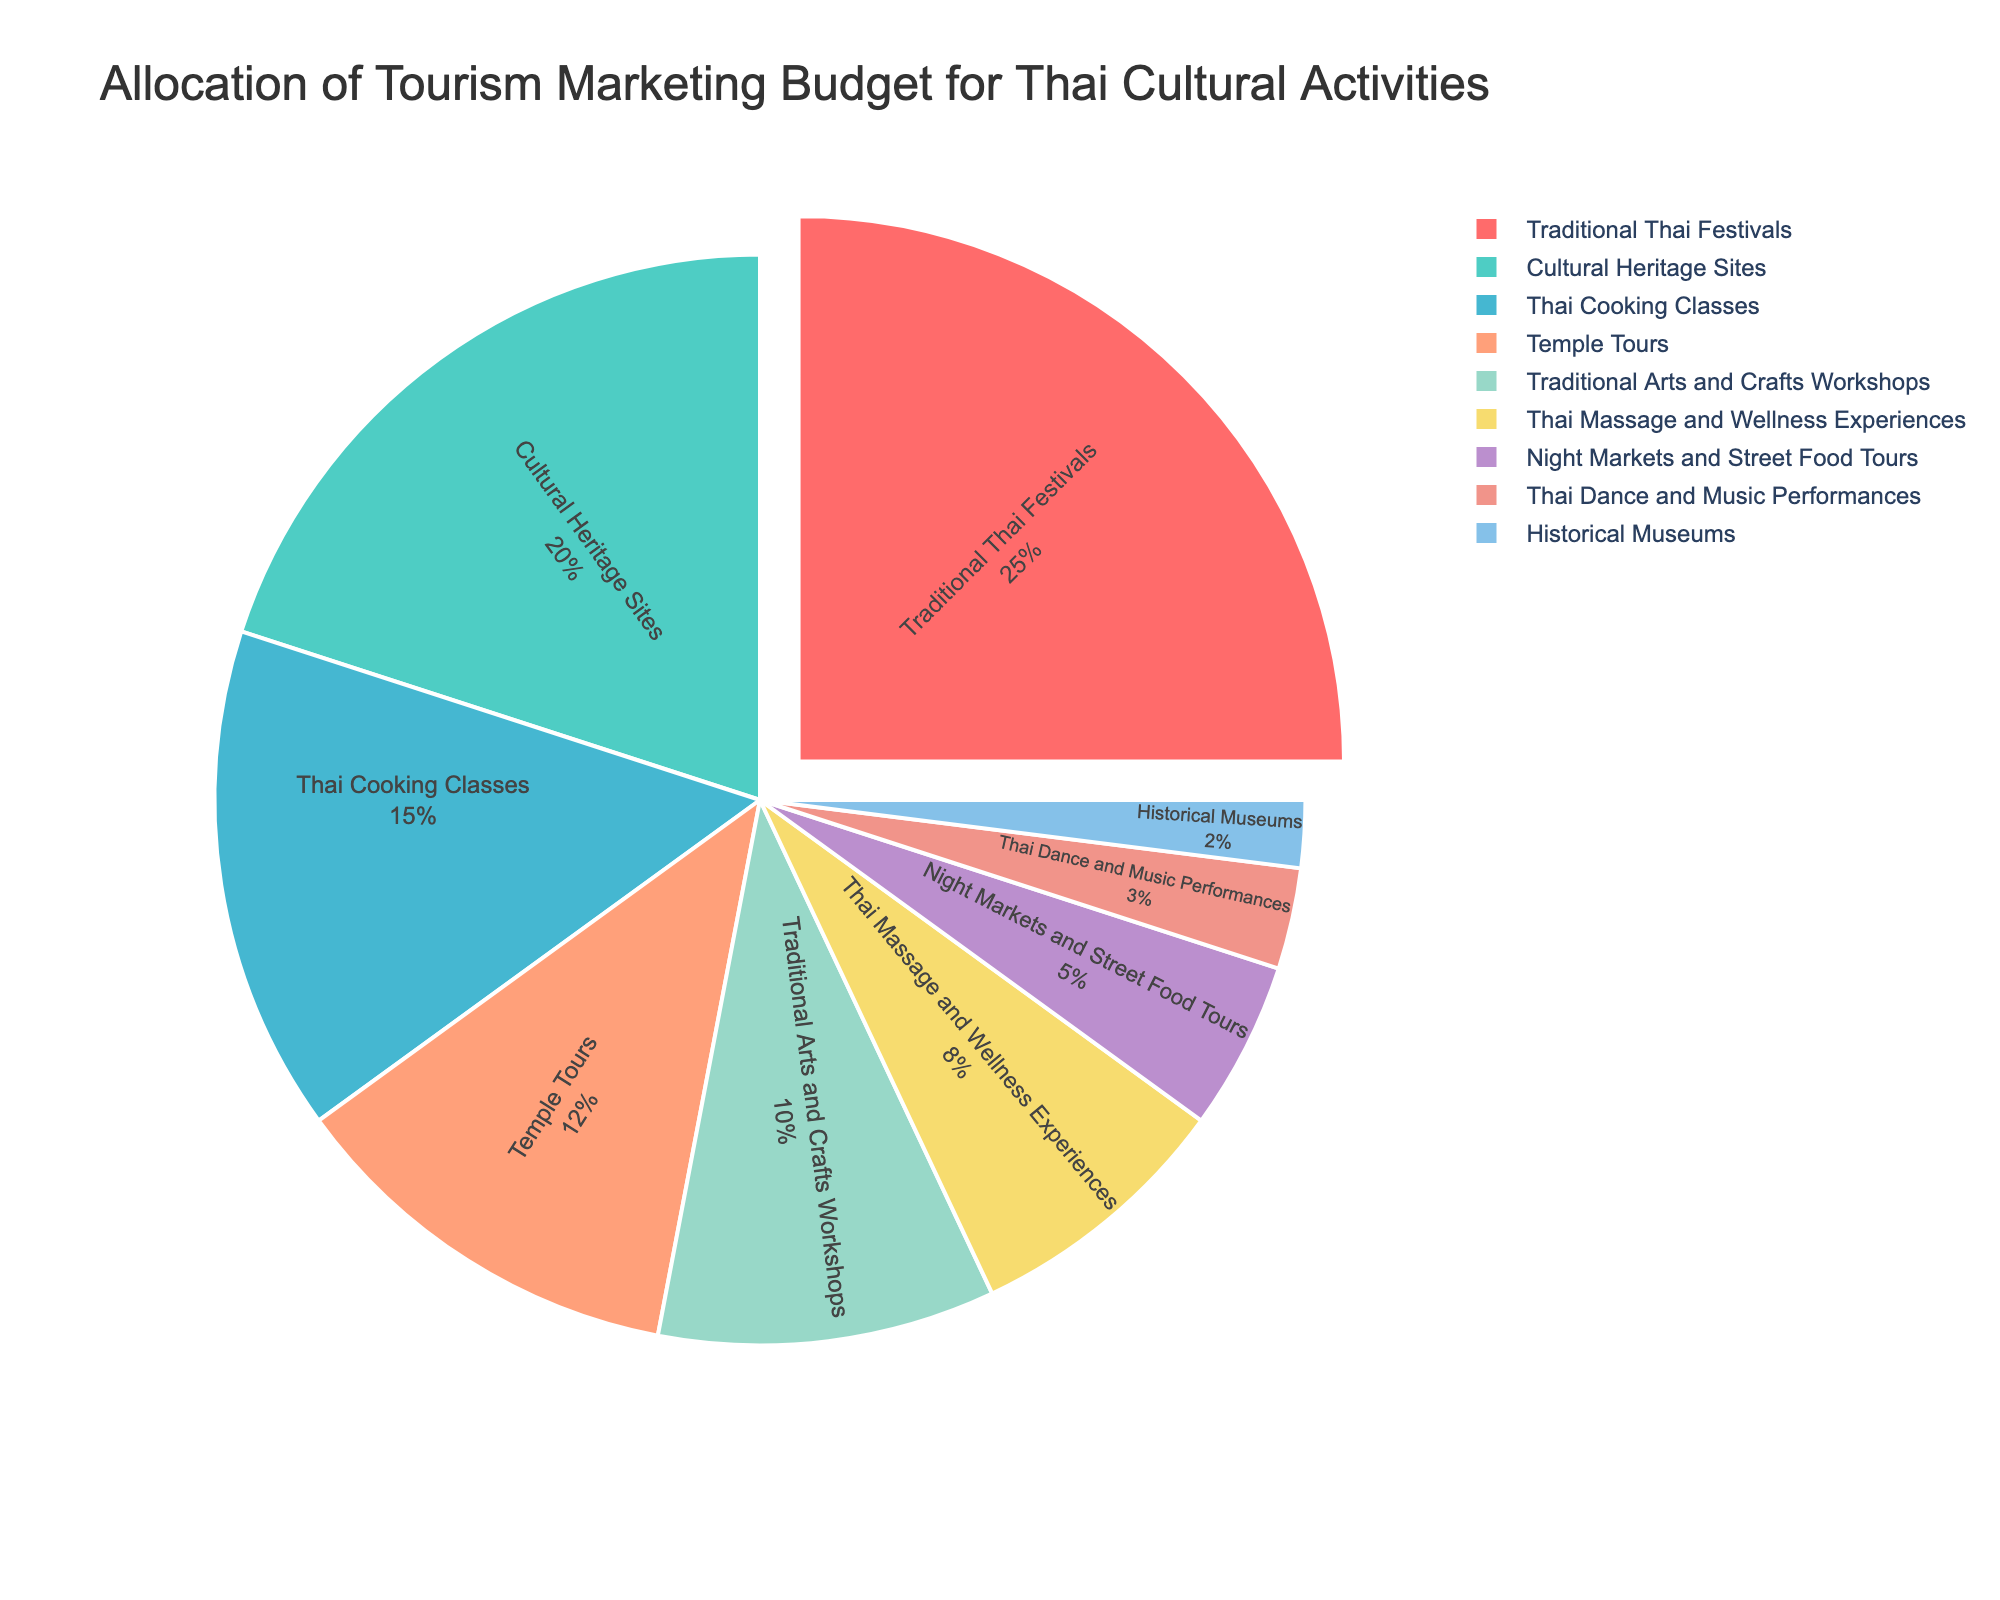What's the largest budget allocation? The pie chart shows that the largest portion of the budget is assigned to Traditional Thai Festivals. This can be seen as it occupies the largest segment of the pie chart.
Answer: 25% Which activities have a budget allocation greater than or equal to 15%? Observing the slices of the pie chart, Traditional Thai Festivals (25%) and Cultural Heritage Sites (20%) each have a budget allocation greater than 15%. Additionally, Thai Cooking Classes have an allocation of 15%.
Answer: Traditional Thai Festivals, Cultural Heritage Sites, Thai Cooking Classes How much more budget is allocated to Traditional Thai Festivals compared to Thai Cooking Classes? The budget for Traditional Thai Festivals is 25%, while for Thai Cooking Classes, it is 15%. Subtracting these gives 25% - 15%.
Answer: 10% Which activity has the least budget allocation? By looking at the smallest slice in the pie chart, Historical Museums have the least budget allocation.
Answer: Historical Museums Which has a higher budget allocation: Temple Tours or Night Markets and Street Food Tours? Comparing the sizes of the slices, Temple Tours have a budget allocation of 12%, while Night Markets and Street Food Tours have a budget allocation of 5%.
Answer: Temple Tours Are there any activities that have a combined allocation equal to Traditional Thai Festivals? If so, which ones? Traditional Thai Festivals have an allocation of 25%. Combining the budgets of Thai Dance and Music Performances (3%) and Historical Museums (2%) gives 5%. Continuing, these combined with Night Markets and Street Food Tours (5%) and Thai Massage and Wellness Experiences (8%) gives a total of 18%. Adding Traditional Arts and Crafts Workshops (10%) exceeds 25%, so there are no two activities whose combined allocation equals Traditional Thai Festivals.
Answer: No What is the combined budget allocation for Traditional Arts and Crafts Workshops and Thai Massage and Wellness Experiences? The allocation for Traditional Arts and Crafts Workshops is 10% and for Thai Massage and Wellness Experiences is 8%. Adding these gives 10% + 8%.
Answer: 18% How does the budget for Night Markets and Street Food Tours compare to Thai Dance and Music Performances? The budget for Night Markets and Street Food Tours is 5%, while Thai Dance and Music Performances have 3%. 5% - 3%.
Answer: 2% more What is the combined budget allocation for all activities excluding Traditional Thai Festivals? Excluding Traditional Thai Festivals (25%), sum the remaining percentages: 20% + 15% + 12% + 10% + 8% + 5% + 3% + 2%.
Answer: 75% What percentage of the budget is allocated to activities related to food? Adding the allocations for Thai Cooking Classes (15%) and Night Markets and Street Food Tours (5%) gives 15% + 5%.
Answer: 20% 